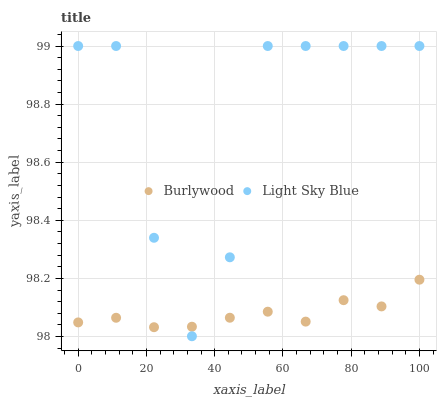Does Burlywood have the minimum area under the curve?
Answer yes or no. Yes. Does Light Sky Blue have the maximum area under the curve?
Answer yes or no. Yes. Does Light Sky Blue have the minimum area under the curve?
Answer yes or no. No. Is Burlywood the smoothest?
Answer yes or no. Yes. Is Light Sky Blue the roughest?
Answer yes or no. Yes. Is Light Sky Blue the smoothest?
Answer yes or no. No. Does Light Sky Blue have the lowest value?
Answer yes or no. Yes. Does Light Sky Blue have the highest value?
Answer yes or no. Yes. Does Light Sky Blue intersect Burlywood?
Answer yes or no. Yes. Is Light Sky Blue less than Burlywood?
Answer yes or no. No. Is Light Sky Blue greater than Burlywood?
Answer yes or no. No. 